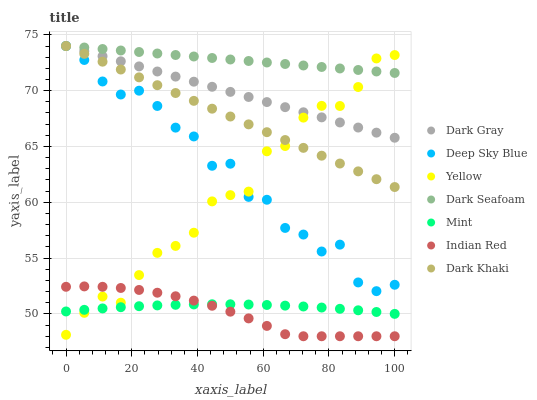Does Indian Red have the minimum area under the curve?
Answer yes or no. Yes. Does Dark Seafoam have the maximum area under the curve?
Answer yes or no. Yes. Does Deep Sky Blue have the minimum area under the curve?
Answer yes or no. No. Does Deep Sky Blue have the maximum area under the curve?
Answer yes or no. No. Is Dark Gray the smoothest?
Answer yes or no. Yes. Is Deep Sky Blue the roughest?
Answer yes or no. Yes. Is Yellow the smoothest?
Answer yes or no. No. Is Yellow the roughest?
Answer yes or no. No. Does Indian Red have the lowest value?
Answer yes or no. Yes. Does Deep Sky Blue have the lowest value?
Answer yes or no. No. Does Dark Seafoam have the highest value?
Answer yes or no. Yes. Does Yellow have the highest value?
Answer yes or no. No. Is Indian Red less than Dark Khaki?
Answer yes or no. Yes. Is Dark Khaki greater than Mint?
Answer yes or no. Yes. Does Deep Sky Blue intersect Yellow?
Answer yes or no. Yes. Is Deep Sky Blue less than Yellow?
Answer yes or no. No. Is Deep Sky Blue greater than Yellow?
Answer yes or no. No. Does Indian Red intersect Dark Khaki?
Answer yes or no. No. 